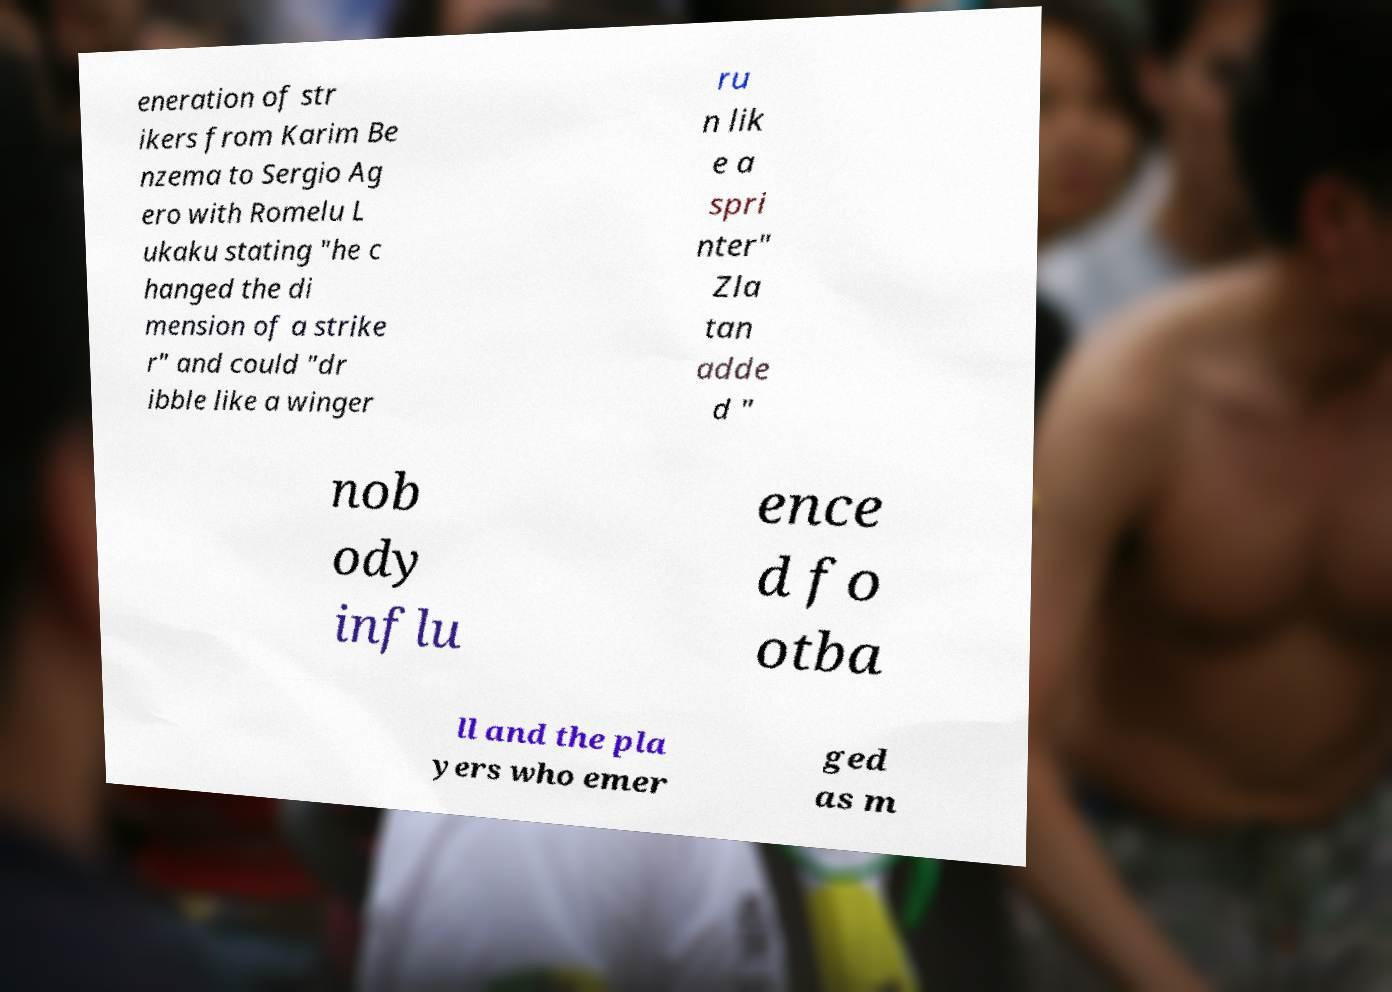I need the written content from this picture converted into text. Can you do that? eneration of str ikers from Karim Be nzema to Sergio Ag ero with Romelu L ukaku stating "he c hanged the di mension of a strike r" and could "dr ibble like a winger ru n lik e a spri nter" Zla tan adde d " nob ody influ ence d fo otba ll and the pla yers who emer ged as m 